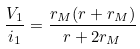<formula> <loc_0><loc_0><loc_500><loc_500>\frac { V _ { 1 } } { i _ { 1 } } = \frac { r _ { M } ( r + r _ { M } ) } { r + 2 r _ { M } }</formula> 